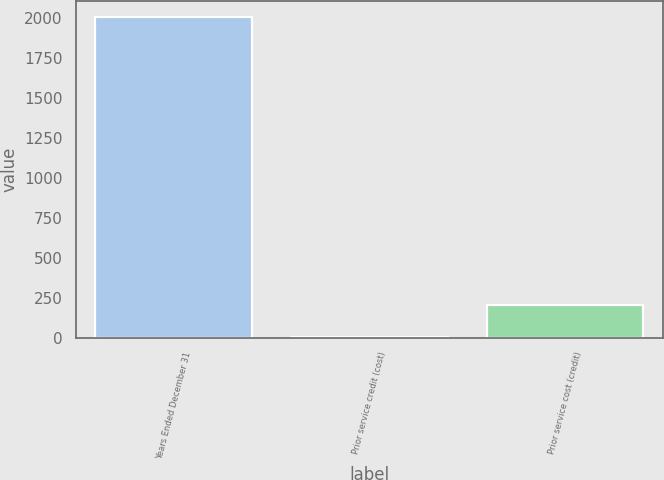<chart> <loc_0><loc_0><loc_500><loc_500><bar_chart><fcel>Years Ended December 31<fcel>Prior service credit (cost)<fcel>Prior service cost (credit)<nl><fcel>2009<fcel>1<fcel>201.8<nl></chart> 